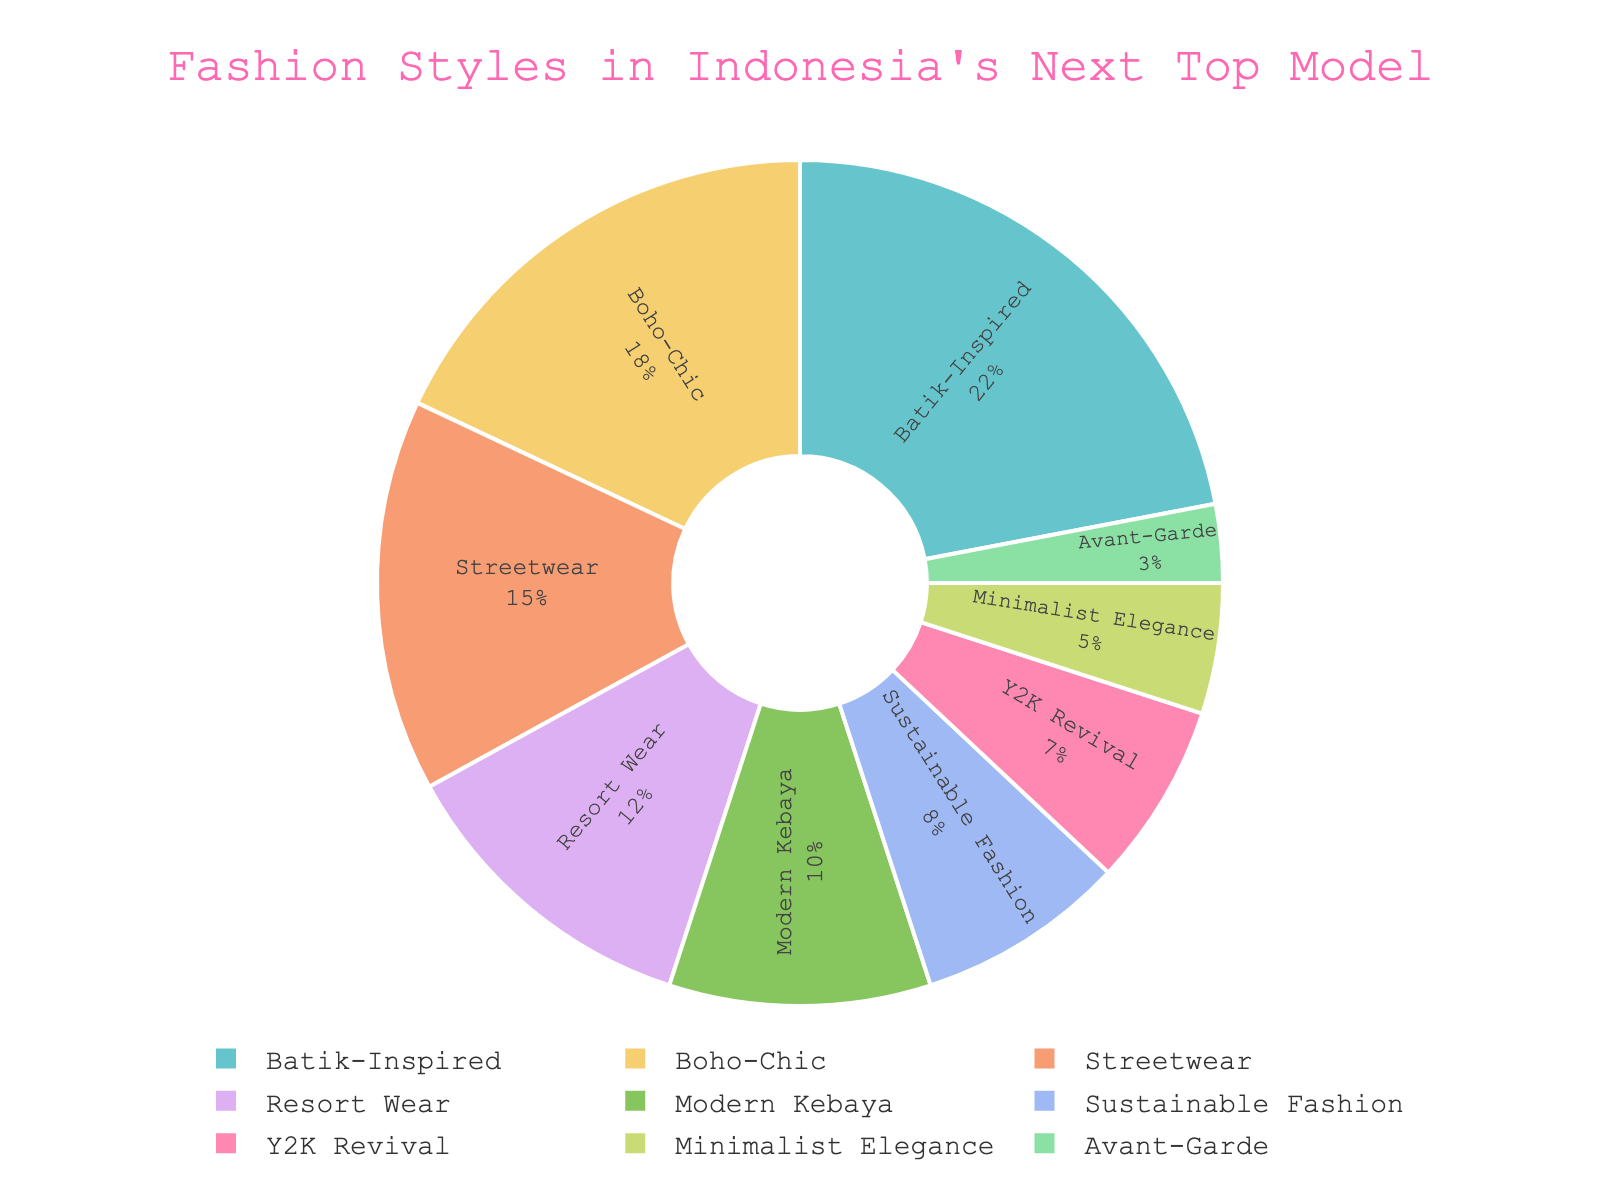What is the most featured fashion style? By looking at the chart, the largest segment represents the most featured style, which is labeled as "Batik-Inspired" with 22%.
Answer: Batik-Inspired Which two fashion styles together make up exactly 30% of the chart? From the percentages in the chart, the two segments that add up to 30% are "Batik-Inspired" (22%) and "Modern Kebaya" (10%).
Answer: Batik-Inspired and Modern Kebaya Which style has a larger share, Sustainable Fashion or Minimalist Elegance? By referring to the chart's segments and their labels, "Sustainable Fashion" is 8% and "Minimalist Elegance" is 5%; hence, Sustainable Fashion is larger.
Answer: Sustainable Fashion How much more percentage does Batik-Inspired have compared to Avant-Garde? The percentage for Batik-Inspired is 22% and for Avant-Garde is 3%. Subtracting these values gives 22% - 3% = 19%.
Answer: 19% What is the combined percentage of Streetwear, Resort Wear, and Y2K Revival? Adding the percentages from the chart, we get: Streetwear (15%) + Resort Wear (12%) + Y2K Revival (7%) = 34%.
Answer: 34% Which fashion style has the smallest representation? The smallest segment in the pie chart is labeled as "Avant-Garde", which is 3%.
Answer: Avant-Garde How many styles have a percentage greater than 10%? By checking the chart, the styles with percentages greater than 10% are Batik-Inspired (22%), Boho-Chic (18%), and Streetwear (15%), and Resort Wear (12%). This totals to 4 styles.
Answer: 4 Is the total percentage of Boho-Chic, Minimalist Elegance, and Modern Kebaya greater than Batik-Inspired? Summing up the percentages we get: Boho-Chic (18%) + Minimalist Elegance (5%) + Modern Kebaya (10%) = 33%. Compared to Batik-Inspired's 22%, yes, it is greater.
Answer: Yes What is the average percentage of Avant-Garde, Minimalist Elegance, and Sustainable Fashion? Adding the percentages: Avant-Garde (3%) + Minimalist Elegance (5%) + Sustainable Fashion (8%) = 16%. Dividing by 3, the average is 16% / 3 ≈ 5.33%.
Answer: 5.33% What are the two fashion styles with the closest percentages, and what are their values? Examining the percentages, the closest ones are Modern Kebaya (10%) and Sustainable Fashion (8%), which have a difference of 2%.
Answer: Modern Kebaya and Sustainable Fashion 